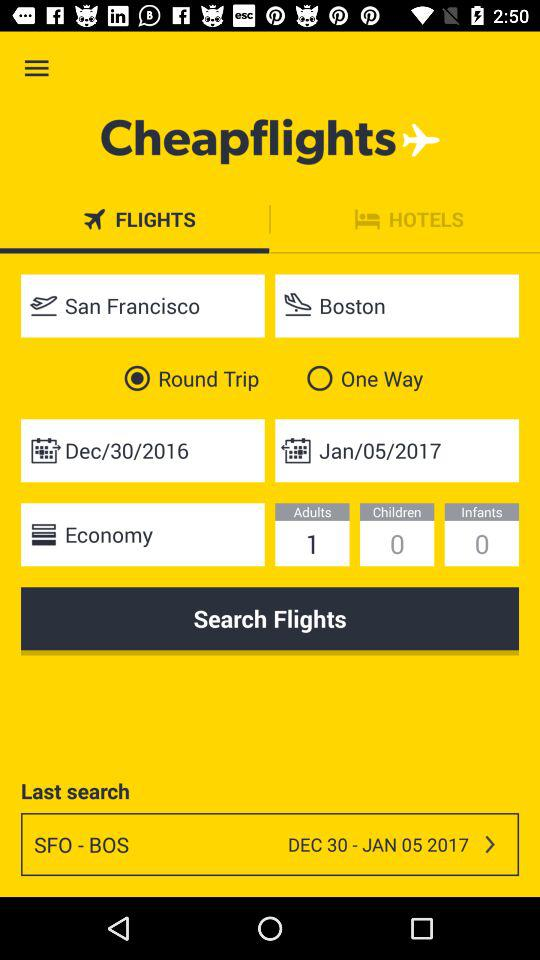How many adults are flying?
Answer the question using a single word or phrase. 1 